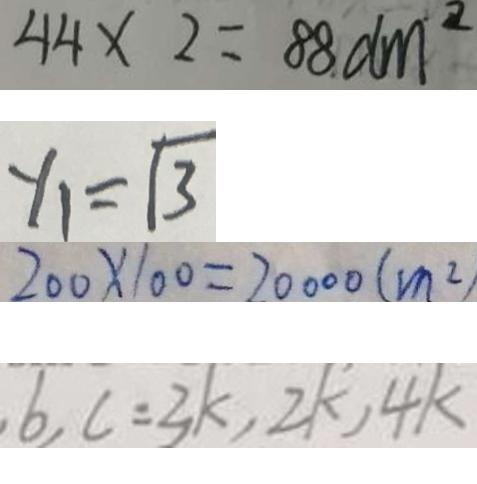<formula> <loc_0><loc_0><loc_500><loc_500>4 4 \times 2 = 8 8 d m ^ { 2 } 
 y _ { 1 } = \sqrt { 3 } 
 2 0 0 \times 1 0 0 = 2 0 0 0 0 ( m ^ { 2 } ) 
 6 , c = 3 k , 2 k , 4 k</formula> 